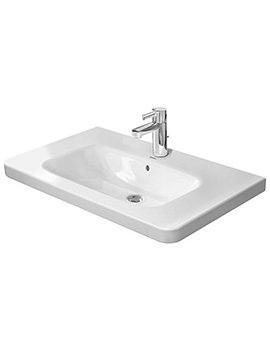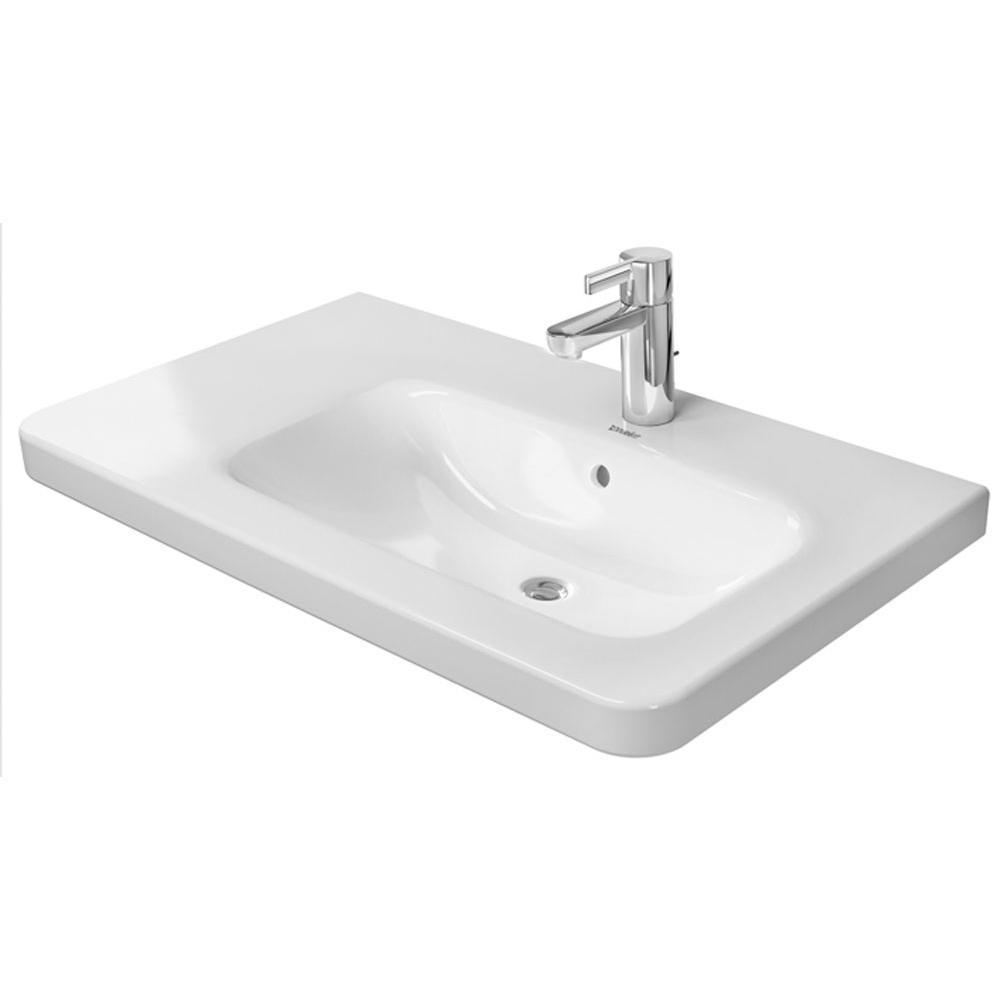The first image is the image on the left, the second image is the image on the right. Assess this claim about the two images: "Each sink is a single-basin design inset in a white rectangle that is straight across the front.". Correct or not? Answer yes or no. Yes. 